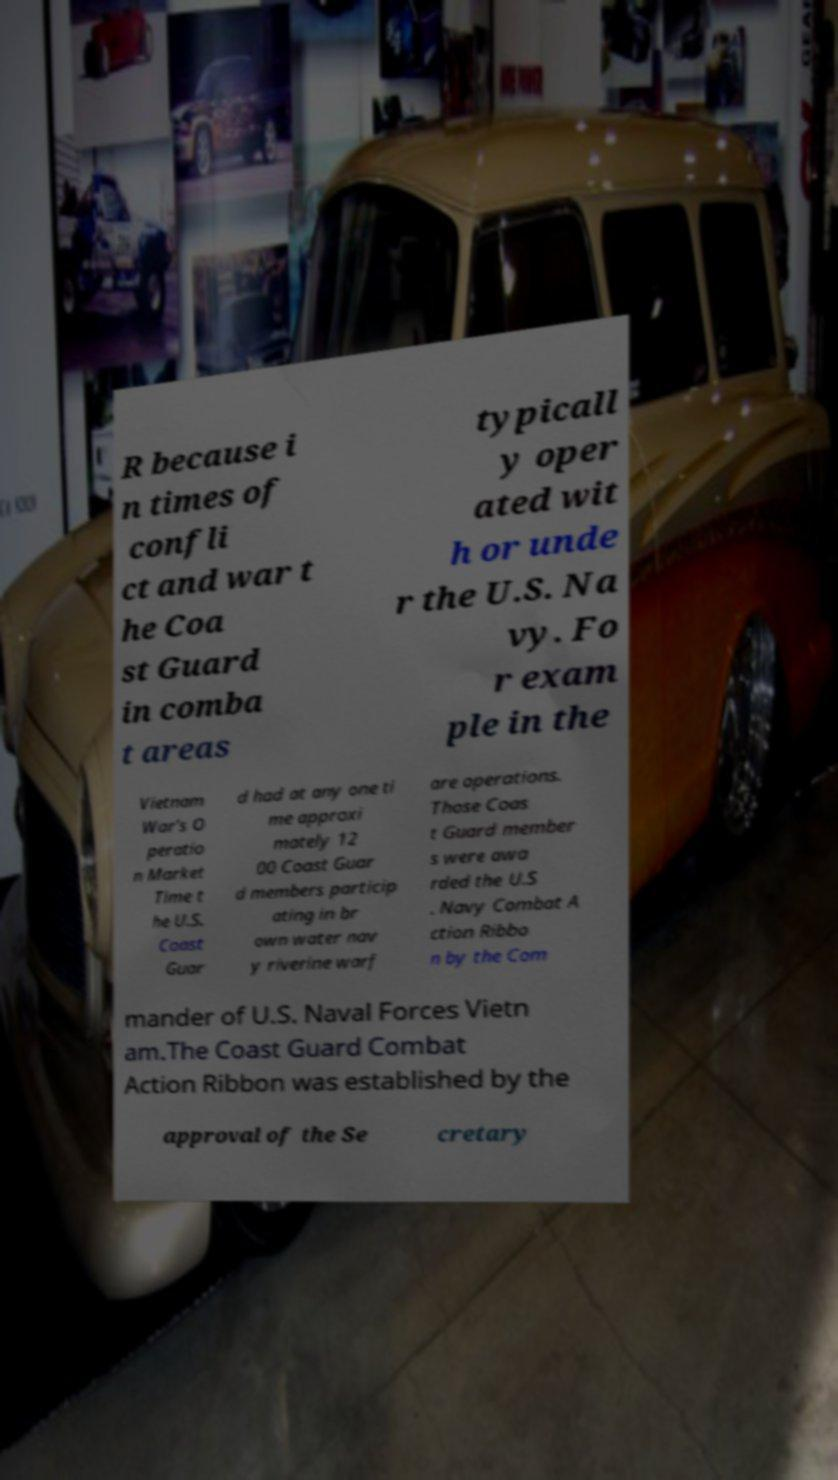Could you extract and type out the text from this image? R because i n times of confli ct and war t he Coa st Guard in comba t areas typicall y oper ated wit h or unde r the U.S. Na vy. Fo r exam ple in the Vietnam War's O peratio n Market Time t he U.S. Coast Guar d had at any one ti me approxi mately 12 00 Coast Guar d members particip ating in br own water nav y riverine warf are operations. Those Coas t Guard member s were awa rded the U.S . Navy Combat A ction Ribbo n by the Com mander of U.S. Naval Forces Vietn am.The Coast Guard Combat Action Ribbon was established by the approval of the Se cretary 